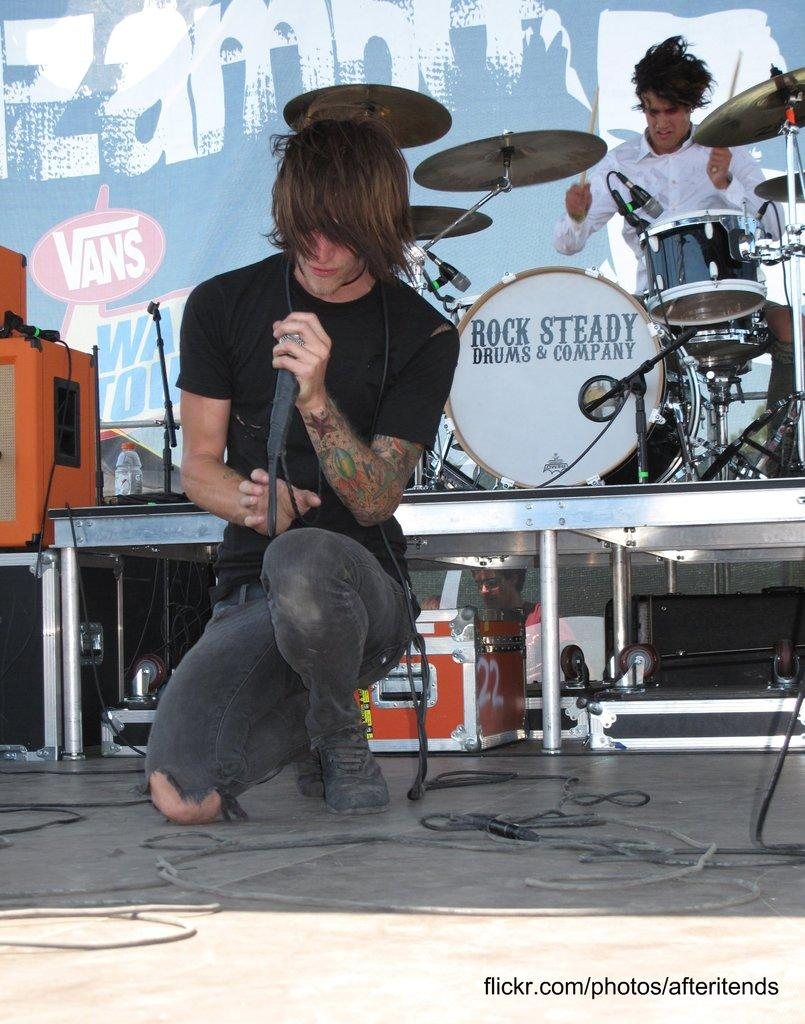What is the person holding in the image? The person is holding a microphone in the image. What is the other person doing in the image? The other person is playing musical instruments in the image. What objects can be seen in the image that might be used for storage or organization? There are boxes visible in the image. What type of furniture is present in the image? There are tables in the image. What additional decorative or informative element can be seen in the image? There is a banner in the image. What type of hammer is being used to take measurements in the image? There is no hammer or measurement activity present in the image. What type of note is being passed between the two people in the image? There is no note being passed between the two people in the image. 